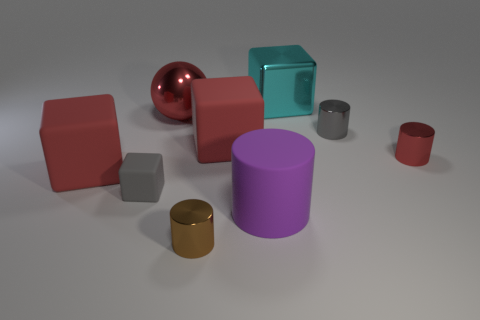Add 1 large metallic cubes. How many objects exist? 10 Subtract all spheres. How many objects are left? 8 Subtract all spheres. Subtract all tiny gray shiny cylinders. How many objects are left? 7 Add 6 small metallic objects. How many small metallic objects are left? 9 Add 9 cyan cubes. How many cyan cubes exist? 10 Subtract 0 blue cylinders. How many objects are left? 9 